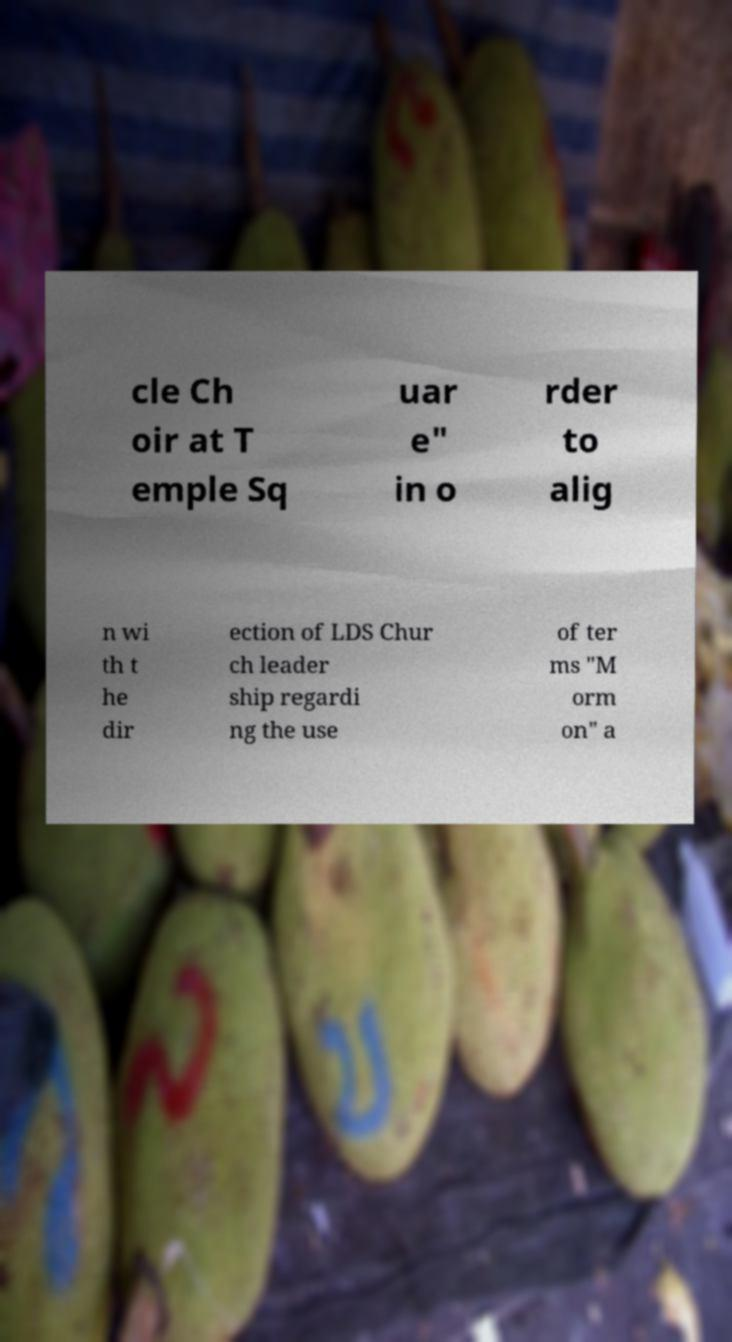For documentation purposes, I need the text within this image transcribed. Could you provide that? cle Ch oir at T emple Sq uar e" in o rder to alig n wi th t he dir ection of LDS Chur ch leader ship regardi ng the use of ter ms "M orm on" a 